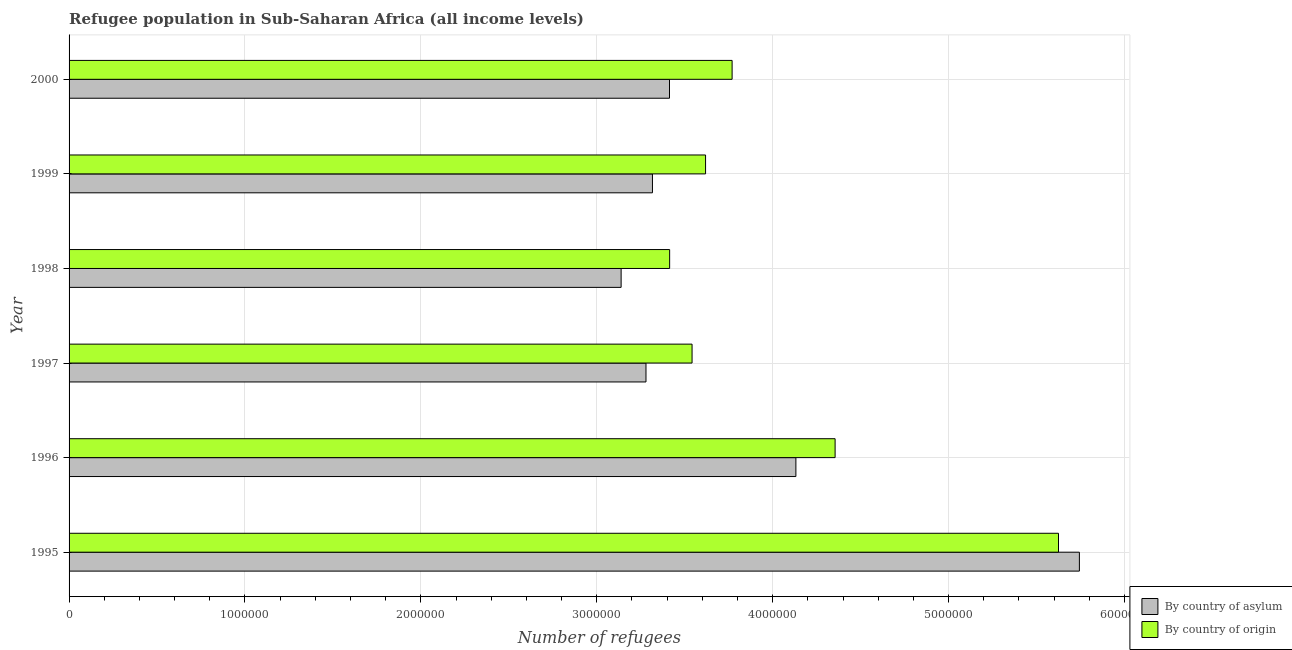How many groups of bars are there?
Your answer should be compact. 6. How many bars are there on the 4th tick from the top?
Provide a short and direct response. 2. How many bars are there on the 5th tick from the bottom?
Keep it short and to the point. 2. In how many cases, is the number of bars for a given year not equal to the number of legend labels?
Keep it short and to the point. 0. What is the number of refugees by country of asylum in 1998?
Provide a short and direct response. 3.14e+06. Across all years, what is the maximum number of refugees by country of origin?
Provide a succinct answer. 5.62e+06. Across all years, what is the minimum number of refugees by country of origin?
Give a very brief answer. 3.41e+06. What is the total number of refugees by country of origin in the graph?
Provide a succinct answer. 2.43e+07. What is the difference between the number of refugees by country of origin in 1996 and that in 1997?
Provide a short and direct response. 8.13e+05. What is the difference between the number of refugees by country of origin in 2000 and the number of refugees by country of asylum in 1998?
Offer a very short reply. 6.31e+05. What is the average number of refugees by country of asylum per year?
Ensure brevity in your answer.  3.84e+06. In the year 1996, what is the difference between the number of refugees by country of asylum and number of refugees by country of origin?
Offer a terse response. -2.23e+05. In how many years, is the number of refugees by country of origin greater than 5800000 ?
Ensure brevity in your answer.  0. What is the ratio of the number of refugees by country of origin in 1995 to that in 1996?
Make the answer very short. 1.29. Is the number of refugees by country of origin in 1995 less than that in 1996?
Provide a short and direct response. No. Is the difference between the number of refugees by country of asylum in 1995 and 2000 greater than the difference between the number of refugees by country of origin in 1995 and 2000?
Offer a terse response. Yes. What is the difference between the highest and the second highest number of refugees by country of asylum?
Offer a terse response. 1.61e+06. What is the difference between the highest and the lowest number of refugees by country of origin?
Your answer should be very brief. 2.21e+06. In how many years, is the number of refugees by country of asylum greater than the average number of refugees by country of asylum taken over all years?
Make the answer very short. 2. Is the sum of the number of refugees by country of origin in 1997 and 1998 greater than the maximum number of refugees by country of asylum across all years?
Provide a succinct answer. Yes. What does the 2nd bar from the top in 1997 represents?
Provide a short and direct response. By country of asylum. What does the 1st bar from the bottom in 1998 represents?
Ensure brevity in your answer.  By country of asylum. How many bars are there?
Make the answer very short. 12. Are all the bars in the graph horizontal?
Provide a succinct answer. Yes. How many years are there in the graph?
Keep it short and to the point. 6. Does the graph contain grids?
Ensure brevity in your answer.  Yes. What is the title of the graph?
Make the answer very short. Refugee population in Sub-Saharan Africa (all income levels). What is the label or title of the X-axis?
Make the answer very short. Number of refugees. What is the label or title of the Y-axis?
Your answer should be very brief. Year. What is the Number of refugees of By country of asylum in 1995?
Your answer should be very brief. 5.74e+06. What is the Number of refugees in By country of origin in 1995?
Provide a succinct answer. 5.62e+06. What is the Number of refugees in By country of asylum in 1996?
Offer a very short reply. 4.13e+06. What is the Number of refugees of By country of origin in 1996?
Your answer should be compact. 4.35e+06. What is the Number of refugees of By country of asylum in 1997?
Your answer should be very brief. 3.28e+06. What is the Number of refugees of By country of origin in 1997?
Your answer should be very brief. 3.54e+06. What is the Number of refugees of By country of asylum in 1998?
Provide a short and direct response. 3.14e+06. What is the Number of refugees of By country of origin in 1998?
Provide a short and direct response. 3.41e+06. What is the Number of refugees of By country of asylum in 1999?
Provide a short and direct response. 3.32e+06. What is the Number of refugees of By country of origin in 1999?
Keep it short and to the point. 3.62e+06. What is the Number of refugees of By country of asylum in 2000?
Make the answer very short. 3.41e+06. What is the Number of refugees in By country of origin in 2000?
Your response must be concise. 3.77e+06. Across all years, what is the maximum Number of refugees in By country of asylum?
Keep it short and to the point. 5.74e+06. Across all years, what is the maximum Number of refugees in By country of origin?
Your response must be concise. 5.62e+06. Across all years, what is the minimum Number of refugees of By country of asylum?
Offer a very short reply. 3.14e+06. Across all years, what is the minimum Number of refugees in By country of origin?
Provide a succinct answer. 3.41e+06. What is the total Number of refugees in By country of asylum in the graph?
Your response must be concise. 2.30e+07. What is the total Number of refugees in By country of origin in the graph?
Make the answer very short. 2.43e+07. What is the difference between the Number of refugees of By country of asylum in 1995 and that in 1996?
Give a very brief answer. 1.61e+06. What is the difference between the Number of refugees in By country of origin in 1995 and that in 1996?
Ensure brevity in your answer.  1.27e+06. What is the difference between the Number of refugees in By country of asylum in 1995 and that in 1997?
Your answer should be compact. 2.46e+06. What is the difference between the Number of refugees of By country of origin in 1995 and that in 1997?
Your response must be concise. 2.08e+06. What is the difference between the Number of refugees of By country of asylum in 1995 and that in 1998?
Provide a short and direct response. 2.61e+06. What is the difference between the Number of refugees of By country of origin in 1995 and that in 1998?
Provide a succinct answer. 2.21e+06. What is the difference between the Number of refugees in By country of asylum in 1995 and that in 1999?
Your response must be concise. 2.43e+06. What is the difference between the Number of refugees of By country of origin in 1995 and that in 1999?
Provide a short and direct response. 2.01e+06. What is the difference between the Number of refugees in By country of asylum in 1995 and that in 2000?
Keep it short and to the point. 2.33e+06. What is the difference between the Number of refugees in By country of origin in 1995 and that in 2000?
Keep it short and to the point. 1.86e+06. What is the difference between the Number of refugees in By country of asylum in 1996 and that in 1997?
Provide a short and direct response. 8.52e+05. What is the difference between the Number of refugees of By country of origin in 1996 and that in 1997?
Offer a terse response. 8.13e+05. What is the difference between the Number of refugees of By country of asylum in 1996 and that in 1998?
Offer a very short reply. 9.94e+05. What is the difference between the Number of refugees in By country of origin in 1996 and that in 1998?
Your answer should be very brief. 9.41e+05. What is the difference between the Number of refugees of By country of asylum in 1996 and that in 1999?
Your answer should be compact. 8.15e+05. What is the difference between the Number of refugees of By country of origin in 1996 and that in 1999?
Make the answer very short. 7.36e+05. What is the difference between the Number of refugees in By country of asylum in 1996 and that in 2000?
Provide a succinct answer. 7.19e+05. What is the difference between the Number of refugees in By country of origin in 1996 and that in 2000?
Your answer should be compact. 5.86e+05. What is the difference between the Number of refugees in By country of asylum in 1997 and that in 1998?
Keep it short and to the point. 1.41e+05. What is the difference between the Number of refugees of By country of origin in 1997 and that in 1998?
Give a very brief answer. 1.27e+05. What is the difference between the Number of refugees of By country of asylum in 1997 and that in 1999?
Offer a terse response. -3.68e+04. What is the difference between the Number of refugees of By country of origin in 1997 and that in 1999?
Make the answer very short. -7.68e+04. What is the difference between the Number of refugees of By country of asylum in 1997 and that in 2000?
Your answer should be very brief. -1.34e+05. What is the difference between the Number of refugees in By country of origin in 1997 and that in 2000?
Your answer should be compact. -2.28e+05. What is the difference between the Number of refugees of By country of asylum in 1998 and that in 1999?
Offer a very short reply. -1.78e+05. What is the difference between the Number of refugees of By country of origin in 1998 and that in 1999?
Offer a very short reply. -2.04e+05. What is the difference between the Number of refugees of By country of asylum in 1998 and that in 2000?
Offer a terse response. -2.75e+05. What is the difference between the Number of refugees in By country of origin in 1998 and that in 2000?
Keep it short and to the point. -3.55e+05. What is the difference between the Number of refugees in By country of asylum in 1999 and that in 2000?
Provide a succinct answer. -9.69e+04. What is the difference between the Number of refugees in By country of origin in 1999 and that in 2000?
Offer a very short reply. -1.51e+05. What is the difference between the Number of refugees of By country of asylum in 1995 and the Number of refugees of By country of origin in 1996?
Give a very brief answer. 1.39e+06. What is the difference between the Number of refugees of By country of asylum in 1995 and the Number of refugees of By country of origin in 1997?
Give a very brief answer. 2.20e+06. What is the difference between the Number of refugees in By country of asylum in 1995 and the Number of refugees in By country of origin in 1998?
Make the answer very short. 2.33e+06. What is the difference between the Number of refugees of By country of asylum in 1995 and the Number of refugees of By country of origin in 1999?
Provide a succinct answer. 2.13e+06. What is the difference between the Number of refugees in By country of asylum in 1995 and the Number of refugees in By country of origin in 2000?
Provide a succinct answer. 1.97e+06. What is the difference between the Number of refugees in By country of asylum in 1996 and the Number of refugees in By country of origin in 1997?
Provide a succinct answer. 5.90e+05. What is the difference between the Number of refugees of By country of asylum in 1996 and the Number of refugees of By country of origin in 1998?
Provide a succinct answer. 7.18e+05. What is the difference between the Number of refugees of By country of asylum in 1996 and the Number of refugees of By country of origin in 1999?
Offer a terse response. 5.14e+05. What is the difference between the Number of refugees in By country of asylum in 1996 and the Number of refugees in By country of origin in 2000?
Your answer should be compact. 3.63e+05. What is the difference between the Number of refugees in By country of asylum in 1997 and the Number of refugees in By country of origin in 1998?
Your answer should be very brief. -1.35e+05. What is the difference between the Number of refugees of By country of asylum in 1997 and the Number of refugees of By country of origin in 1999?
Give a very brief answer. -3.39e+05. What is the difference between the Number of refugees in By country of asylum in 1997 and the Number of refugees in By country of origin in 2000?
Offer a very short reply. -4.90e+05. What is the difference between the Number of refugees of By country of asylum in 1998 and the Number of refugees of By country of origin in 1999?
Ensure brevity in your answer.  -4.80e+05. What is the difference between the Number of refugees of By country of asylum in 1998 and the Number of refugees of By country of origin in 2000?
Ensure brevity in your answer.  -6.31e+05. What is the difference between the Number of refugees in By country of asylum in 1999 and the Number of refugees in By country of origin in 2000?
Your response must be concise. -4.53e+05. What is the average Number of refugees of By country of asylum per year?
Offer a very short reply. 3.84e+06. What is the average Number of refugees of By country of origin per year?
Make the answer very short. 4.05e+06. In the year 1995, what is the difference between the Number of refugees in By country of asylum and Number of refugees in By country of origin?
Your answer should be very brief. 1.19e+05. In the year 1996, what is the difference between the Number of refugees in By country of asylum and Number of refugees in By country of origin?
Your answer should be very brief. -2.23e+05. In the year 1997, what is the difference between the Number of refugees in By country of asylum and Number of refugees in By country of origin?
Keep it short and to the point. -2.62e+05. In the year 1998, what is the difference between the Number of refugees of By country of asylum and Number of refugees of By country of origin?
Offer a terse response. -2.76e+05. In the year 1999, what is the difference between the Number of refugees in By country of asylum and Number of refugees in By country of origin?
Offer a very short reply. -3.02e+05. In the year 2000, what is the difference between the Number of refugees of By country of asylum and Number of refugees of By country of origin?
Make the answer very short. -3.56e+05. What is the ratio of the Number of refugees of By country of asylum in 1995 to that in 1996?
Make the answer very short. 1.39. What is the ratio of the Number of refugees of By country of origin in 1995 to that in 1996?
Your answer should be compact. 1.29. What is the ratio of the Number of refugees of By country of asylum in 1995 to that in 1997?
Ensure brevity in your answer.  1.75. What is the ratio of the Number of refugees in By country of origin in 1995 to that in 1997?
Your answer should be very brief. 1.59. What is the ratio of the Number of refugees in By country of asylum in 1995 to that in 1998?
Ensure brevity in your answer.  1.83. What is the ratio of the Number of refugees of By country of origin in 1995 to that in 1998?
Offer a very short reply. 1.65. What is the ratio of the Number of refugees in By country of asylum in 1995 to that in 1999?
Ensure brevity in your answer.  1.73. What is the ratio of the Number of refugees of By country of origin in 1995 to that in 1999?
Your answer should be compact. 1.55. What is the ratio of the Number of refugees in By country of asylum in 1995 to that in 2000?
Provide a short and direct response. 1.68. What is the ratio of the Number of refugees of By country of origin in 1995 to that in 2000?
Make the answer very short. 1.49. What is the ratio of the Number of refugees in By country of asylum in 1996 to that in 1997?
Give a very brief answer. 1.26. What is the ratio of the Number of refugees in By country of origin in 1996 to that in 1997?
Ensure brevity in your answer.  1.23. What is the ratio of the Number of refugees of By country of asylum in 1996 to that in 1998?
Make the answer very short. 1.32. What is the ratio of the Number of refugees in By country of origin in 1996 to that in 1998?
Offer a very short reply. 1.28. What is the ratio of the Number of refugees in By country of asylum in 1996 to that in 1999?
Provide a succinct answer. 1.25. What is the ratio of the Number of refugees of By country of origin in 1996 to that in 1999?
Your answer should be compact. 1.2. What is the ratio of the Number of refugees of By country of asylum in 1996 to that in 2000?
Give a very brief answer. 1.21. What is the ratio of the Number of refugees in By country of origin in 1996 to that in 2000?
Your response must be concise. 1.16. What is the ratio of the Number of refugees of By country of asylum in 1997 to that in 1998?
Your answer should be compact. 1.04. What is the ratio of the Number of refugees of By country of origin in 1997 to that in 1998?
Give a very brief answer. 1.04. What is the ratio of the Number of refugees in By country of asylum in 1997 to that in 1999?
Your answer should be compact. 0.99. What is the ratio of the Number of refugees in By country of origin in 1997 to that in 1999?
Provide a succinct answer. 0.98. What is the ratio of the Number of refugees in By country of asylum in 1997 to that in 2000?
Offer a terse response. 0.96. What is the ratio of the Number of refugees of By country of origin in 1997 to that in 2000?
Provide a short and direct response. 0.94. What is the ratio of the Number of refugees in By country of asylum in 1998 to that in 1999?
Provide a succinct answer. 0.95. What is the ratio of the Number of refugees of By country of origin in 1998 to that in 1999?
Give a very brief answer. 0.94. What is the ratio of the Number of refugees of By country of asylum in 1998 to that in 2000?
Make the answer very short. 0.92. What is the ratio of the Number of refugees of By country of origin in 1998 to that in 2000?
Your answer should be very brief. 0.91. What is the ratio of the Number of refugees of By country of asylum in 1999 to that in 2000?
Keep it short and to the point. 0.97. What is the ratio of the Number of refugees in By country of origin in 1999 to that in 2000?
Your answer should be very brief. 0.96. What is the difference between the highest and the second highest Number of refugees in By country of asylum?
Your answer should be compact. 1.61e+06. What is the difference between the highest and the second highest Number of refugees in By country of origin?
Provide a succinct answer. 1.27e+06. What is the difference between the highest and the lowest Number of refugees of By country of asylum?
Offer a terse response. 2.61e+06. What is the difference between the highest and the lowest Number of refugees of By country of origin?
Make the answer very short. 2.21e+06. 